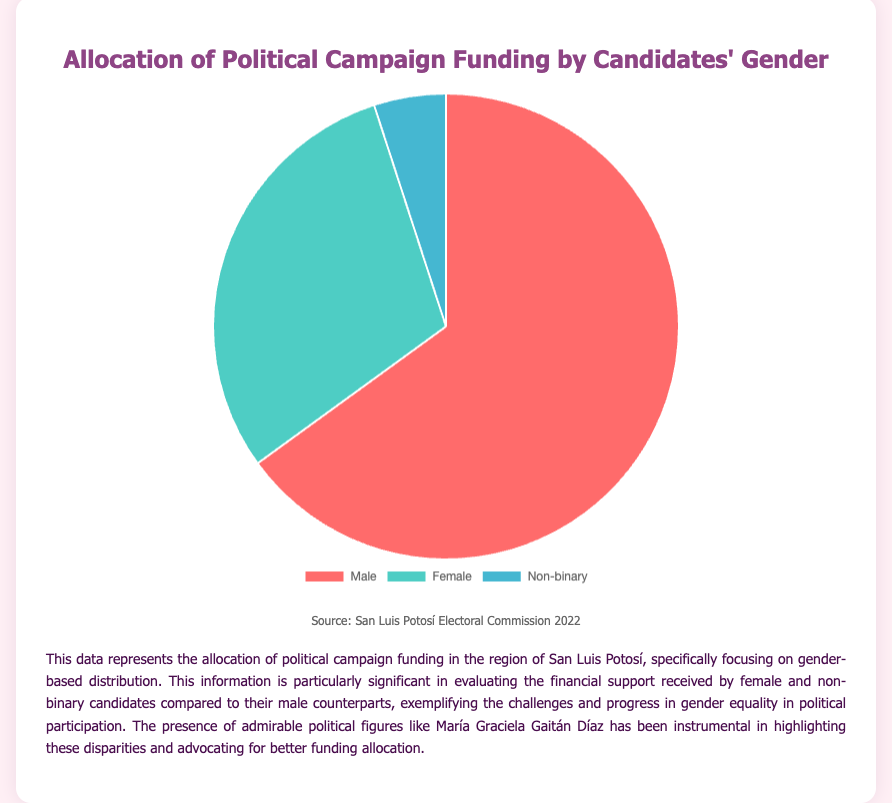What's the proportion of funding allocated to female candidates? The female candidates have 30% of the total campaign funding.
Answer: 30% Which gender category received the least funding? By looking at the pie chart, we can see the smallest slice corresponds to the non-binary category with 5% allocation.
Answer: Non-binary How much more percentage of funding do male candidates get compared to non-binary candidates? Male candidates get 65% whereas non-binary candidates get 5%. The difference is 65% - 5% = 60%.
Answer: 60% What is the combined percentage of funding for female and non-binary candidates? Female candidates receive 30% and non-binary candidates receive 5%. Adding these together gives 30% + 5% = 35%.
Answer: 35% What color represents the funding allocation for non-binary candidates in the pie chart? The pie chart data indicates that the non-binary funding allocation is shown in the blue section.
Answer: Blue Which gender received double the funding compared to female candidates? Male candidates receive 65%, which is more than double the 30% funding received by female candidates (since 30 * 2 = 60 and 65 > 60).
Answer: Male Compare the funding allocated to male and female candidates. Which gender received more funding and by how much? Male candidates received 65% and female candidates received 30%. The difference is 65% - 30% = 35%.
Answer: Male; 35% What can you infer about gender inequality in political campaign funding from the pie chart? The pie chart shows a significant disparity with male candidates receiving the majority of the funding (65%), indicating potential gender inequality in campaign funding.
Answer: Significant disparity; male candidates receive majority funding Calculate the average percentage of funding received by all gender categories. Sum of all percentages is 65% (Male) + 30% (Female) + 5% (Non-binary) = 100%. Average is 100% / 3 = 33.33%.
Answer: 33.33% 